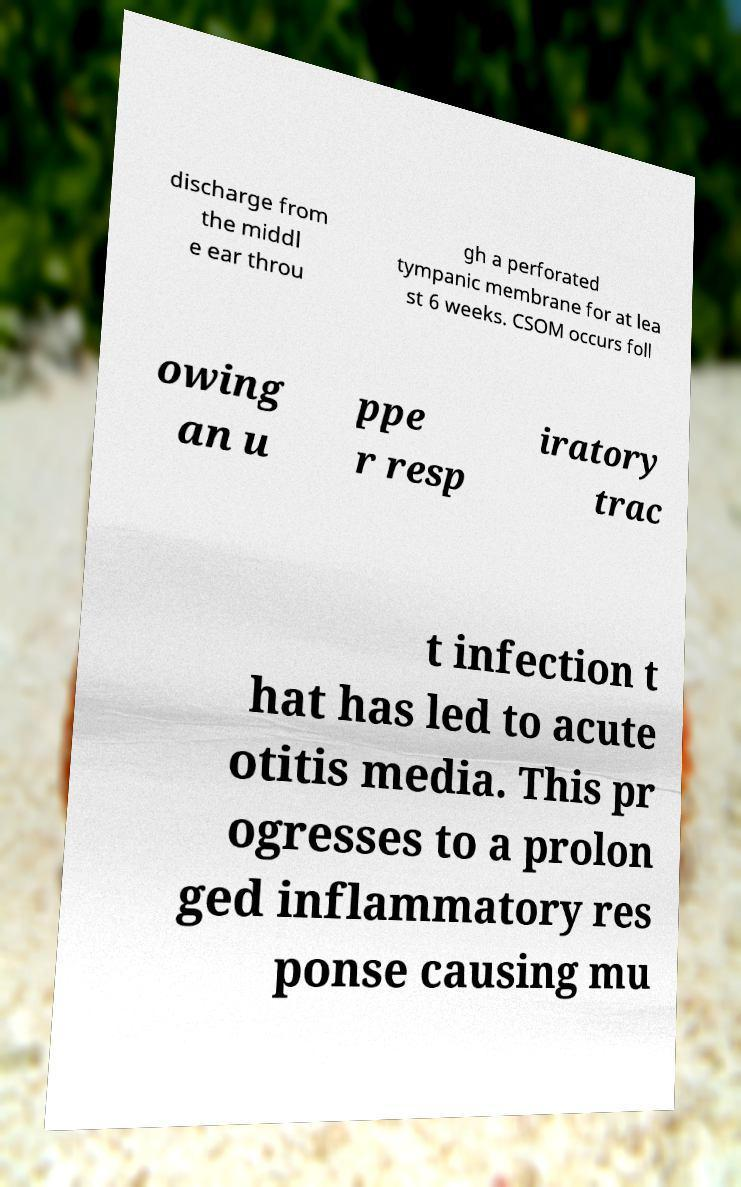Could you extract and type out the text from this image? discharge from the middl e ear throu gh a perforated tympanic membrane for at lea st 6 weeks. CSOM occurs foll owing an u ppe r resp iratory trac t infection t hat has led to acute otitis media. This pr ogresses to a prolon ged inflammatory res ponse causing mu 